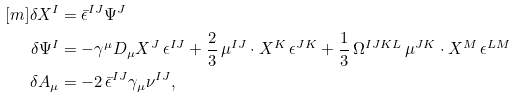Convert formula to latex. <formula><loc_0><loc_0><loc_500><loc_500>[ m ] \delta X ^ { I } & = { \bar { \epsilon } } ^ { I J } \Psi ^ { J } \\ \delta \Psi ^ { I } & = - \gamma ^ { \mu } D _ { \mu } X ^ { J } \, \epsilon ^ { I J } + \frac { 2 } { 3 } \, \mu ^ { I J } \cdot X ^ { K } \, \epsilon ^ { J K } + \frac { 1 } { 3 } \, \Omega ^ { I J K L } \, \mu ^ { J K } \cdot X ^ { M } \, \epsilon ^ { L M } \\ \delta A _ { \mu } & = - 2 \, { \bar { \epsilon } } ^ { I J } \gamma _ { \mu } \nu ^ { I J } ,</formula> 